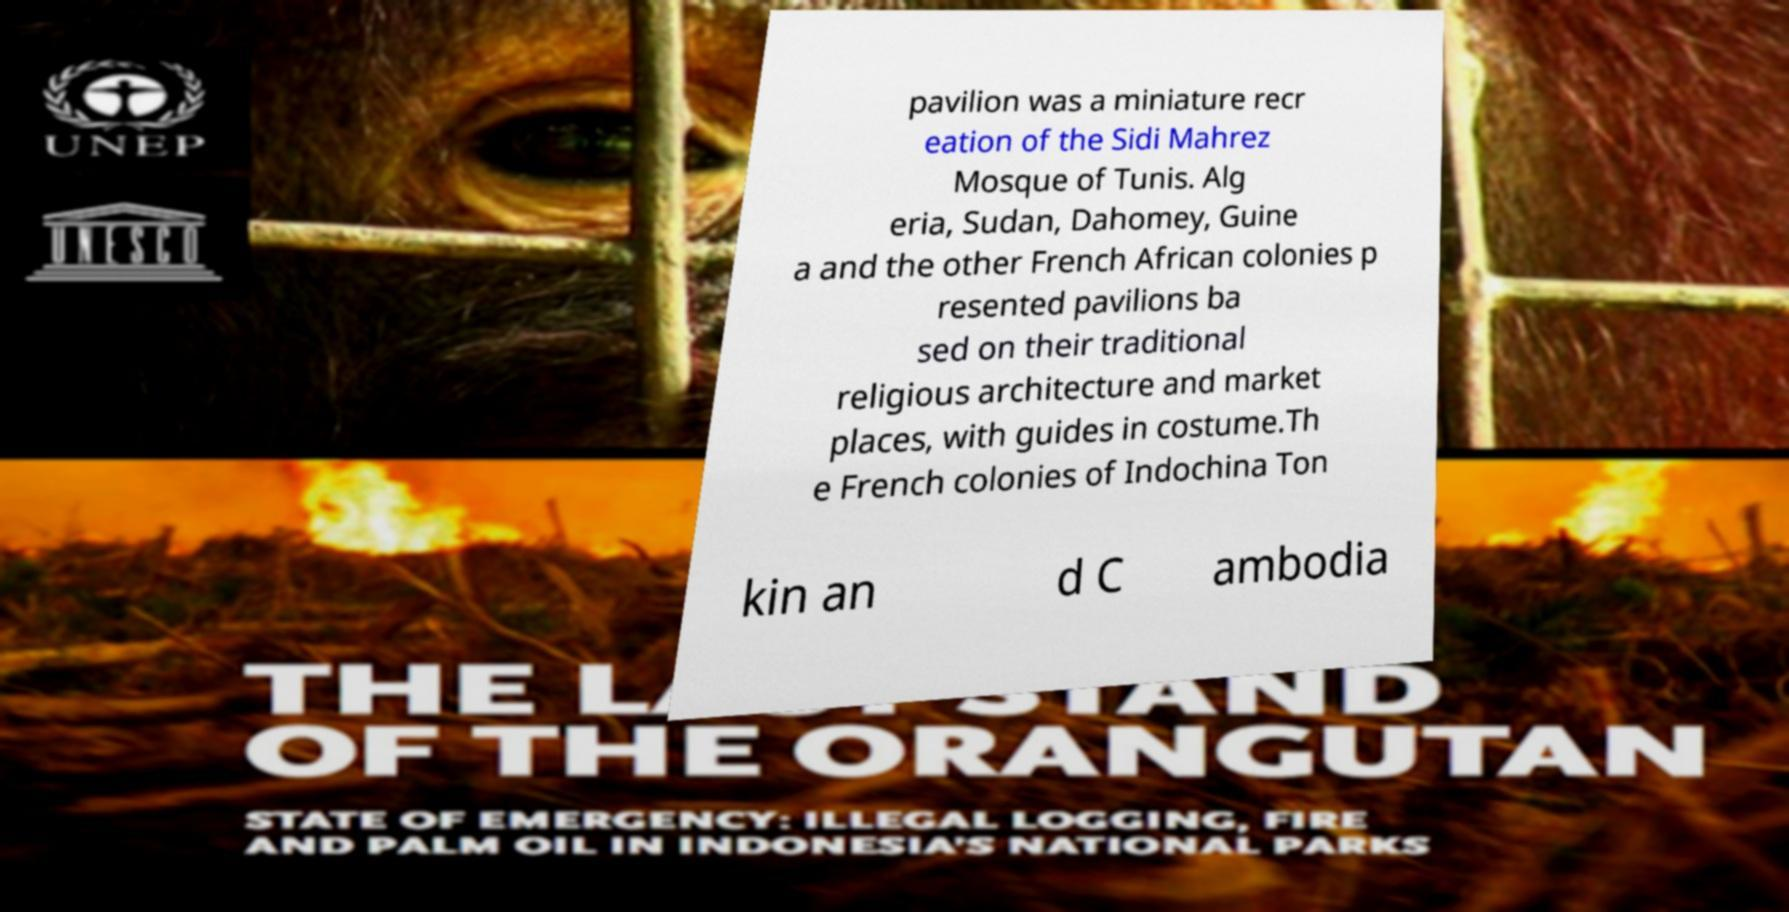Could you extract and type out the text from this image? pavilion was a miniature recr eation of the Sidi Mahrez Mosque of Tunis. Alg eria, Sudan, Dahomey, Guine a and the other French African colonies p resented pavilions ba sed on their traditional religious architecture and market places, with guides in costume.Th e French colonies of Indochina Ton kin an d C ambodia 